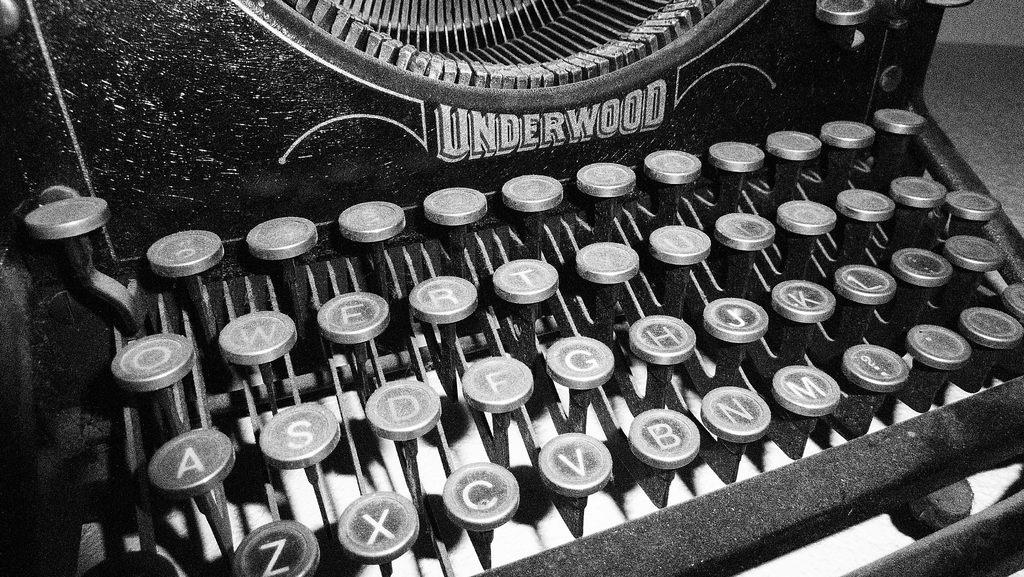<image>
Render a clear and concise summary of the photo. An old manual Underwood typewriter with worn keys. 